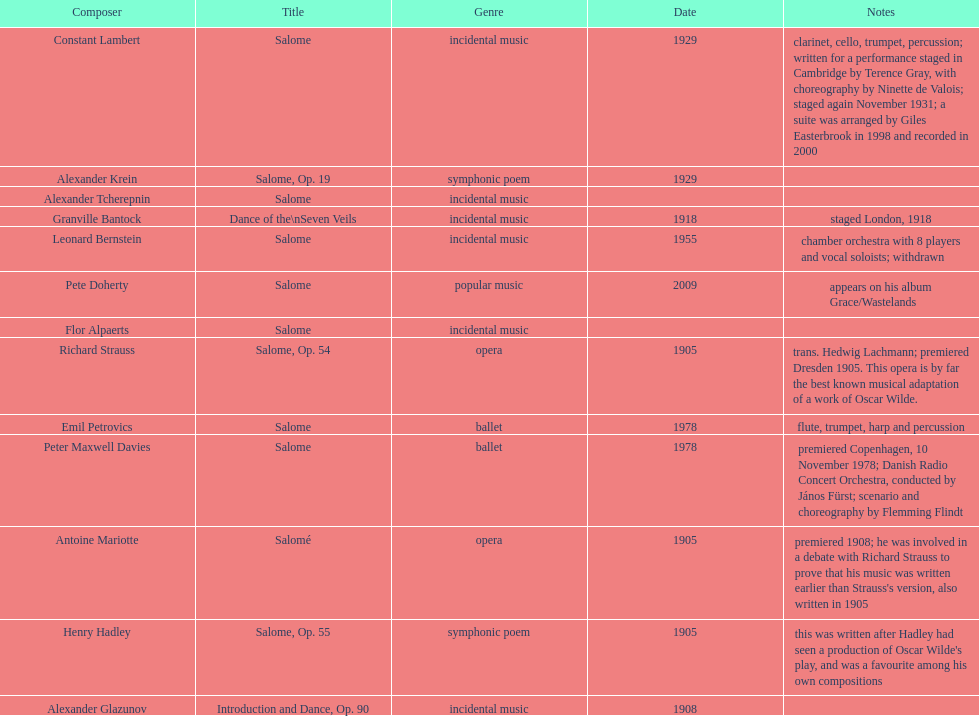Would you mind parsing the complete table? {'header': ['Composer', 'Title', 'Genre', 'Date', 'Notes'], 'rows': [['Constant Lambert', 'Salome', 'incidental music', '1929', 'clarinet, cello, trumpet, percussion; written for a performance staged in Cambridge by Terence Gray, with choreography by Ninette de Valois; staged again November 1931; a suite was arranged by Giles Easterbrook in 1998 and recorded in 2000'], ['Alexander Krein', 'Salome, Op. 19', 'symphonic poem', '1929', ''], ['Alexander\xa0Tcherepnin', 'Salome', 'incidental music', '', ''], ['Granville Bantock', 'Dance of the\\nSeven Veils', 'incidental music', '1918', 'staged London, 1918'], ['Leonard Bernstein', 'Salome', 'incidental music', '1955', 'chamber orchestra with 8 players and vocal soloists; withdrawn'], ['Pete Doherty', 'Salome', 'popular music', '2009', 'appears on his album Grace/Wastelands'], ['Flor Alpaerts', 'Salome', 'incidental\xa0music', '', ''], ['Richard Strauss', 'Salome, Op. 54', 'opera', '1905', 'trans. Hedwig Lachmann; premiered Dresden 1905. This opera is by far the best known musical adaptation of a work of Oscar Wilde.'], ['Emil Petrovics', 'Salome', 'ballet', '1978', 'flute, trumpet, harp and percussion'], ['Peter\xa0Maxwell\xa0Davies', 'Salome', 'ballet', '1978', 'premiered Copenhagen, 10 November 1978; Danish Radio Concert Orchestra, conducted by János Fürst; scenario and choreography by Flemming Flindt'], ['Antoine Mariotte', 'Salomé', 'opera', '1905', "premiered 1908; he was involved in a debate with Richard Strauss to prove that his music was written earlier than Strauss's version, also written in 1905"], ['Henry Hadley', 'Salome, Op. 55', 'symphonic poem', '1905', "this was written after Hadley had seen a production of Oscar Wilde's play, and was a favourite among his own compositions"], ['Alexander Glazunov', 'Introduction and Dance, Op. 90', 'incidental music', '1908', '']]} In the genre of incidental music, how many pieces were produced? 6. 